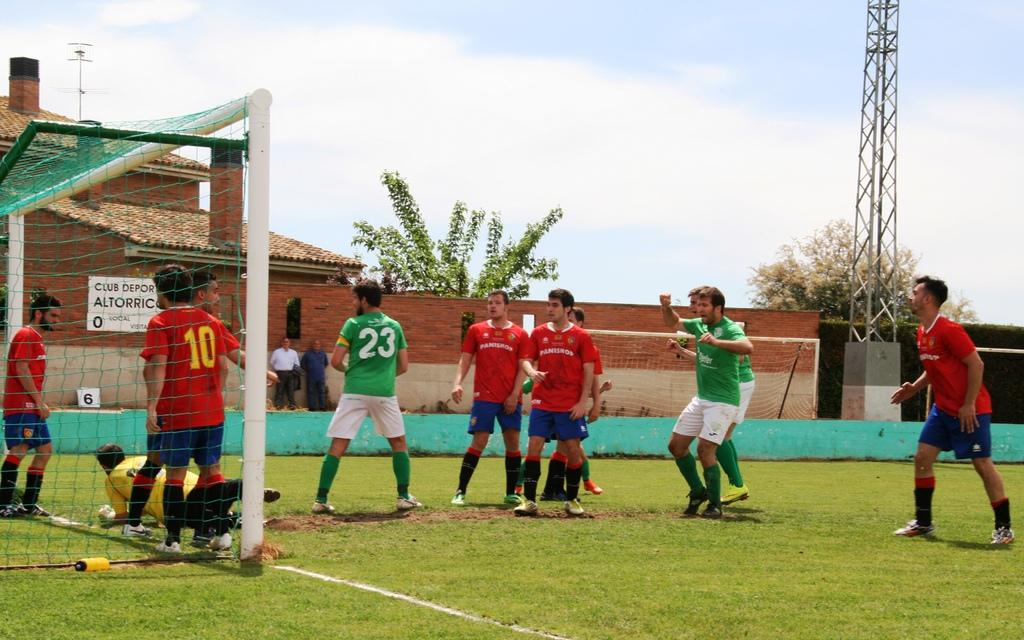Provide a one-sentence caption for the provided image. Members of the team sponsored by Panishop fight for a goal on the soccer field. 